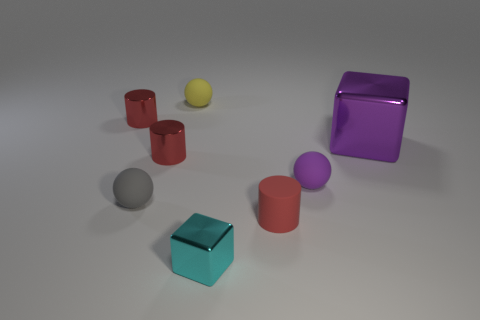Subtract all red cylinders. How many were subtracted if there are1red cylinders left? 2 Subtract all purple matte spheres. How many spheres are left? 2 Add 2 small red objects. How many objects exist? 10 Subtract all cyan balls. Subtract all purple blocks. How many balls are left? 3 Subtract all blocks. How many objects are left? 6 Subtract 0 red spheres. How many objects are left? 8 Subtract all cyan metal blocks. Subtract all big objects. How many objects are left? 6 Add 7 small rubber spheres. How many small rubber spheres are left? 10 Add 3 purple metal cubes. How many purple metal cubes exist? 4 